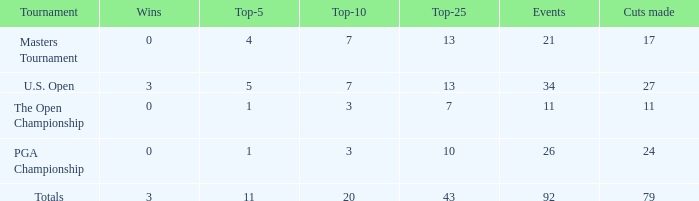Identify the aggregate sum of triumphs with top-25 of 10 and incidents fewer than 2 0.0. 